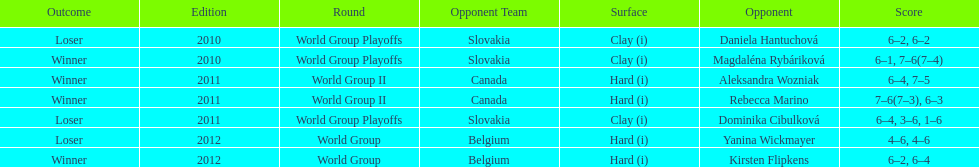What is the other year slovakia played besides 2010? 2011. 